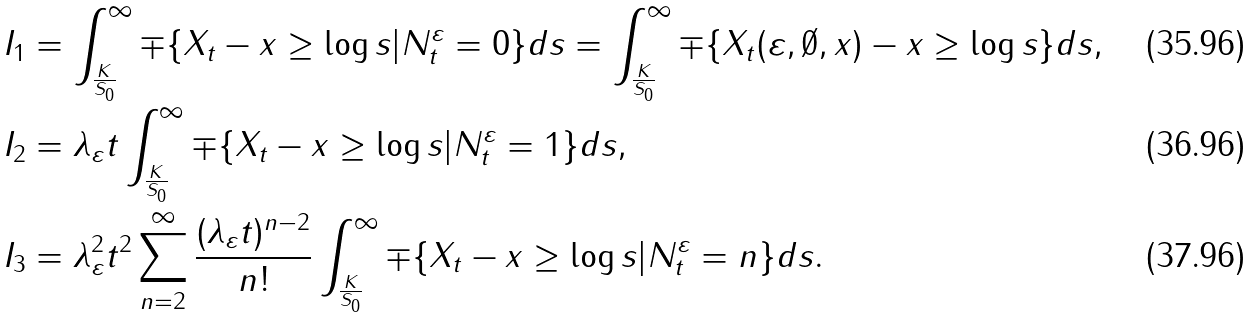Convert formula to latex. <formula><loc_0><loc_0><loc_500><loc_500>& I _ { 1 } = \int _ { \frac { K } { S _ { 0 } } } ^ { \infty } \mp \{ X _ { t } - x \geq \log s | N _ { t } ^ { \varepsilon } = 0 \} d s = \int _ { \frac { K } { S _ { 0 } } } ^ { \infty } \mp \{ X _ { t } ( \varepsilon , \emptyset , x ) - x \geq \log s \} d s , \\ & I _ { 2 } = \lambda _ { \varepsilon } t \int _ { \frac { K } { S _ { 0 } } } ^ { \infty } \mp \{ X _ { t } - x \geq \log s | N _ { t } ^ { \varepsilon } = 1 \} d s , \\ & I _ { 3 } = \lambda _ { \varepsilon } ^ { 2 } t ^ { 2 } \sum _ { n = 2 } ^ { \infty } \frac { ( \lambda _ { \varepsilon } t ) ^ { n - 2 } } { n ! } \int _ { \frac { K } { S _ { 0 } } } ^ { \infty } \mp \{ X _ { t } - x \geq \log s | N _ { t } ^ { \varepsilon } = n \} d s .</formula> 